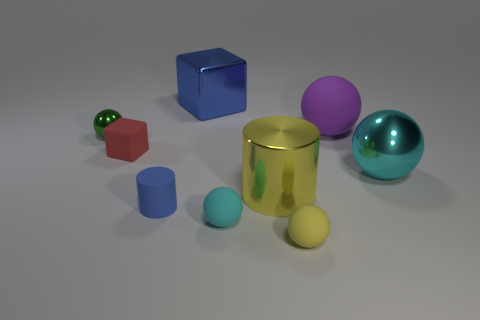Subtract all tiny spheres. How many spheres are left? 2 Subtract all green spheres. How many spheres are left? 4 Subtract all yellow spheres. Subtract all cyan blocks. How many spheres are left? 4 Subtract all cylinders. How many objects are left? 7 Add 4 green metal objects. How many green metal objects are left? 5 Add 3 small metal cylinders. How many small metal cylinders exist? 3 Subtract 0 cyan blocks. How many objects are left? 9 Subtract all tiny blue matte objects. Subtract all gray things. How many objects are left? 8 